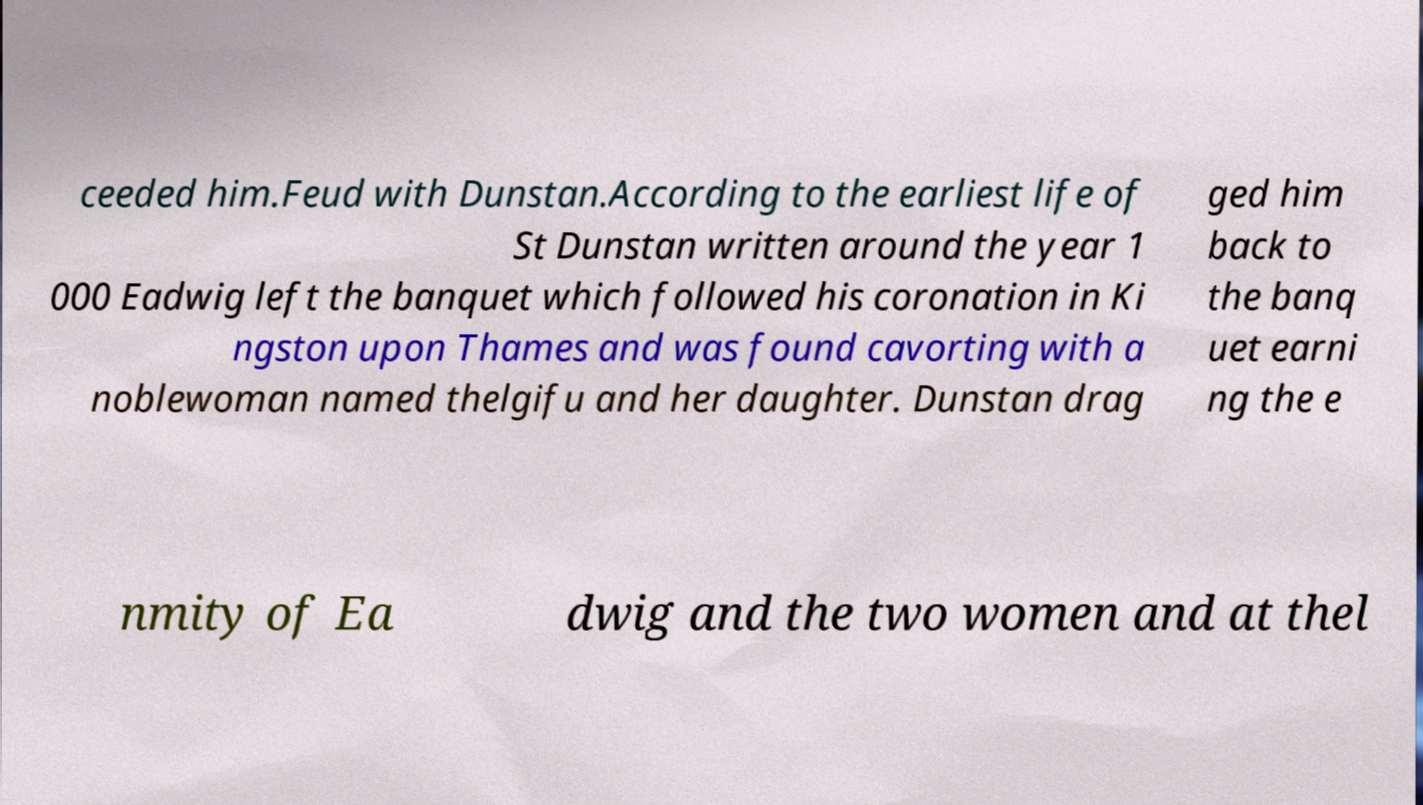For documentation purposes, I need the text within this image transcribed. Could you provide that? ceeded him.Feud with Dunstan.According to the earliest life of St Dunstan written around the year 1 000 Eadwig left the banquet which followed his coronation in Ki ngston upon Thames and was found cavorting with a noblewoman named thelgifu and her daughter. Dunstan drag ged him back to the banq uet earni ng the e nmity of Ea dwig and the two women and at thel 